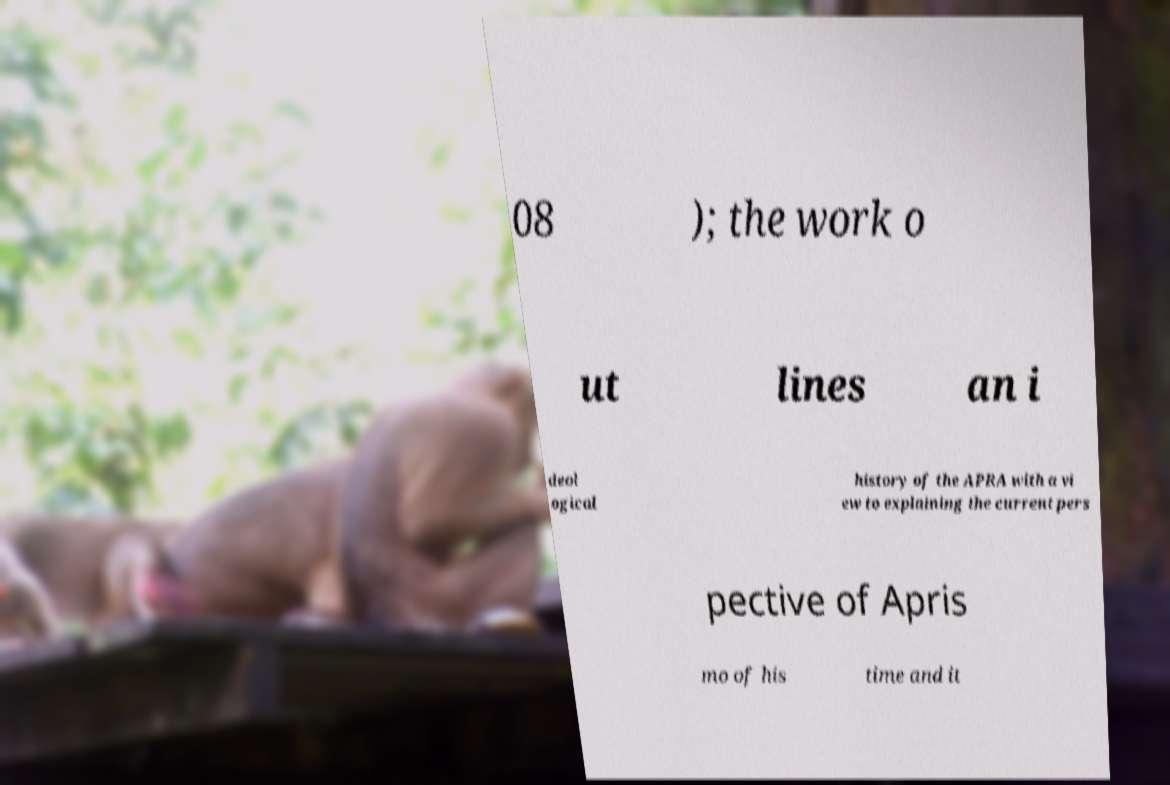Could you extract and type out the text from this image? 08 ); the work o ut lines an i deol ogical history of the APRA with a vi ew to explaining the current pers pective of Apris mo of his time and it 